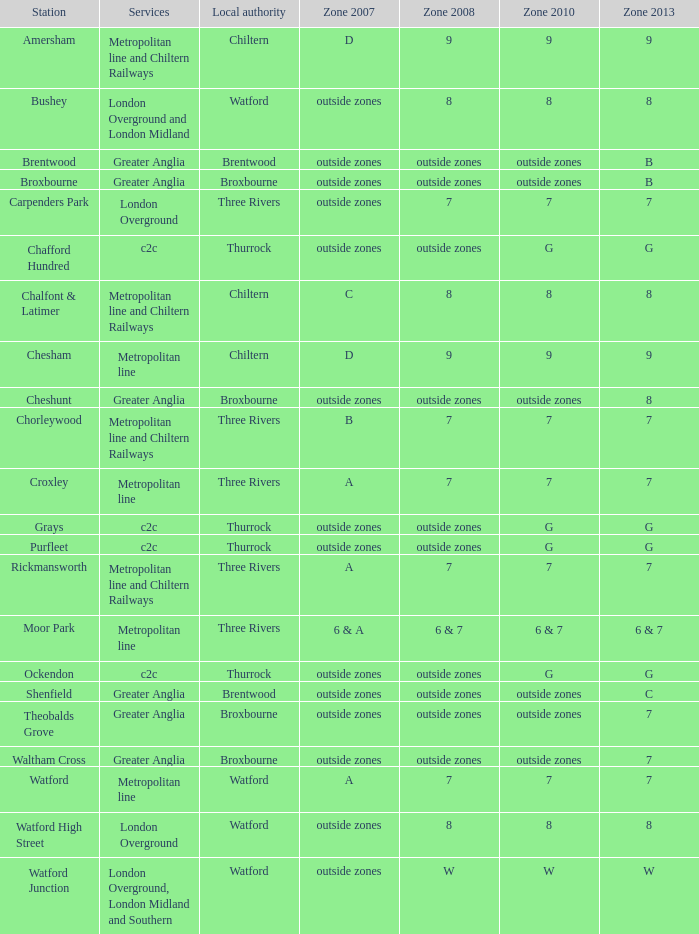I'm looking to parse the entire table for insights. Could you assist me with that? {'header': ['Station', 'Services', 'Local authority', 'Zone 2007', 'Zone 2008', 'Zone 2010', 'Zone 2013'], 'rows': [['Amersham', 'Metropolitan line and Chiltern Railways', 'Chiltern', 'D', '9', '9', '9'], ['Bushey', 'London Overground and London Midland', 'Watford', 'outside zones', '8', '8', '8'], ['Brentwood', 'Greater Anglia', 'Brentwood', 'outside zones', 'outside zones', 'outside zones', 'B'], ['Broxbourne', 'Greater Anglia', 'Broxbourne', 'outside zones', 'outside zones', 'outside zones', 'B'], ['Carpenders Park', 'London Overground', 'Three Rivers', 'outside zones', '7', '7', '7'], ['Chafford Hundred', 'c2c', 'Thurrock', 'outside zones', 'outside zones', 'G', 'G'], ['Chalfont & Latimer', 'Metropolitan line and Chiltern Railways', 'Chiltern', 'C', '8', '8', '8'], ['Chesham', 'Metropolitan line', 'Chiltern', 'D', '9', '9', '9'], ['Cheshunt', 'Greater Anglia', 'Broxbourne', 'outside zones', 'outside zones', 'outside zones', '8'], ['Chorleywood', 'Metropolitan line and Chiltern Railways', 'Three Rivers', 'B', '7', '7', '7'], ['Croxley', 'Metropolitan line', 'Three Rivers', 'A', '7', '7', '7'], ['Grays', 'c2c', 'Thurrock', 'outside zones', 'outside zones', 'G', 'G'], ['Purfleet', 'c2c', 'Thurrock', 'outside zones', 'outside zones', 'G', 'G'], ['Rickmansworth', 'Metropolitan line and Chiltern Railways', 'Three Rivers', 'A', '7', '7', '7'], ['Moor Park', 'Metropolitan line', 'Three Rivers', '6 & A', '6 & 7', '6 & 7', '6 & 7'], ['Ockendon', 'c2c', 'Thurrock', 'outside zones', 'outside zones', 'G', 'G'], ['Shenfield', 'Greater Anglia', 'Brentwood', 'outside zones', 'outside zones', 'outside zones', 'C'], ['Theobalds Grove', 'Greater Anglia', 'Broxbourne', 'outside zones', 'outside zones', 'outside zones', '7'], ['Waltham Cross', 'Greater Anglia', 'Broxbourne', 'outside zones', 'outside zones', 'outside zones', '7'], ['Watford', 'Metropolitan line', 'Watford', 'A', '7', '7', '7'], ['Watford High Street', 'London Overground', 'Watford', 'outside zones', '8', '8', '8'], ['Watford Junction', 'London Overground, London Midland and Southern', 'Watford', 'outside zones', 'W', 'W', 'W']]} Which station holds a zone 2010 equal to 7? Carpenders Park, Chorleywood, Croxley, Rickmansworth, Watford. 